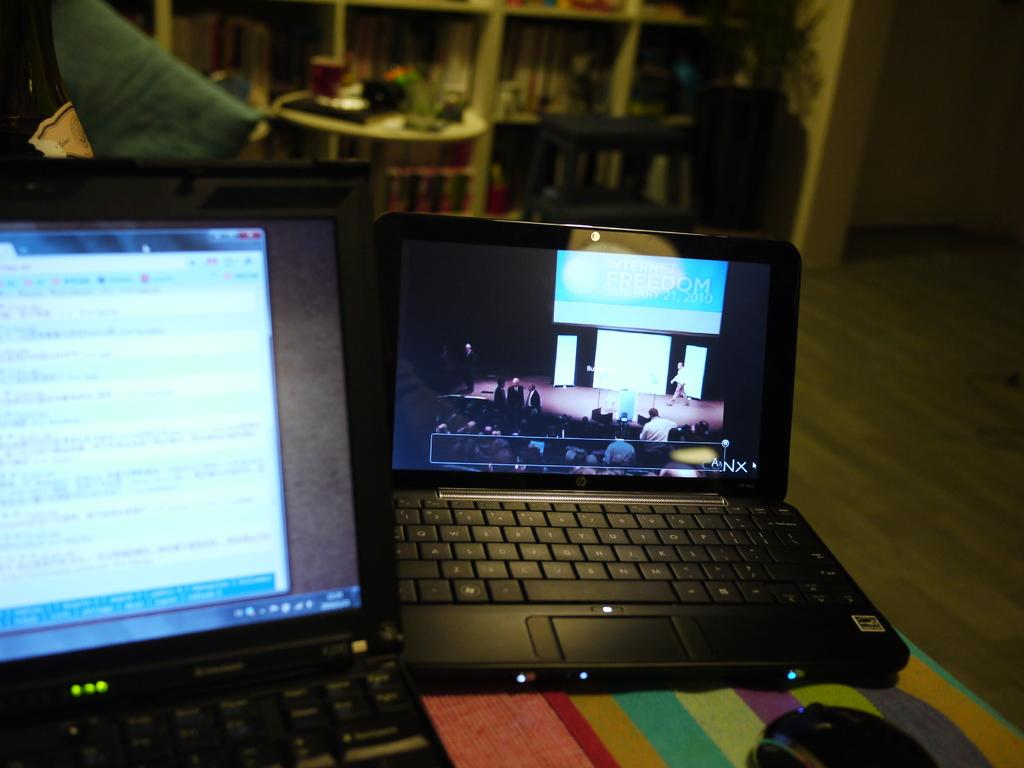<image>
Render a clear and concise summary of the photo. Two laptops sitting on a table with one showing Canx 